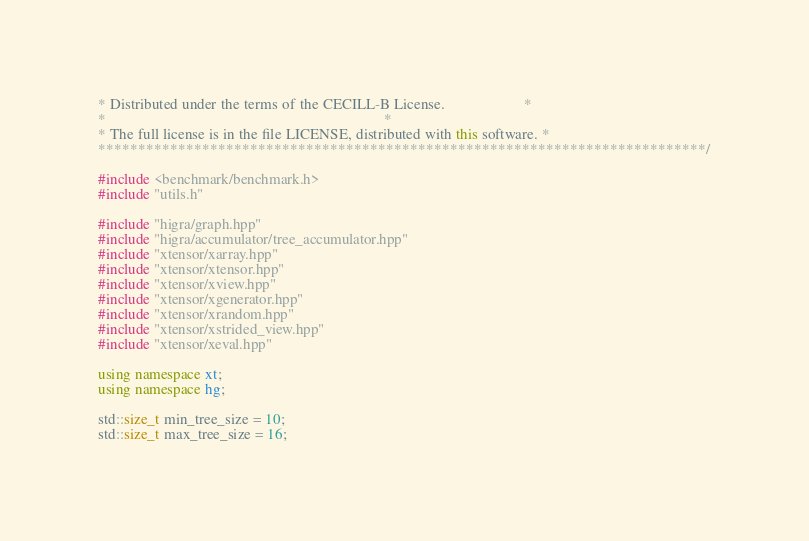Convert code to text. <code><loc_0><loc_0><loc_500><loc_500><_C++_>* Distributed under the terms of the CECILL-B License.                     *
*                                                                          *
* The full license is in the file LICENSE, distributed with this software. *
****************************************************************************/

#include <benchmark/benchmark.h>
#include "utils.h"

#include "higra/graph.hpp"
#include "higra/accumulator/tree_accumulator.hpp"
#include "xtensor/xarray.hpp"
#include "xtensor/xtensor.hpp"
#include "xtensor/xview.hpp"
#include "xtensor/xgenerator.hpp"
#include "xtensor/xrandom.hpp"
#include "xtensor/xstrided_view.hpp"
#include "xtensor/xeval.hpp"

using namespace xt;
using namespace hg;

std::size_t min_tree_size = 10;
std::size_t max_tree_size = 16;


</code> 